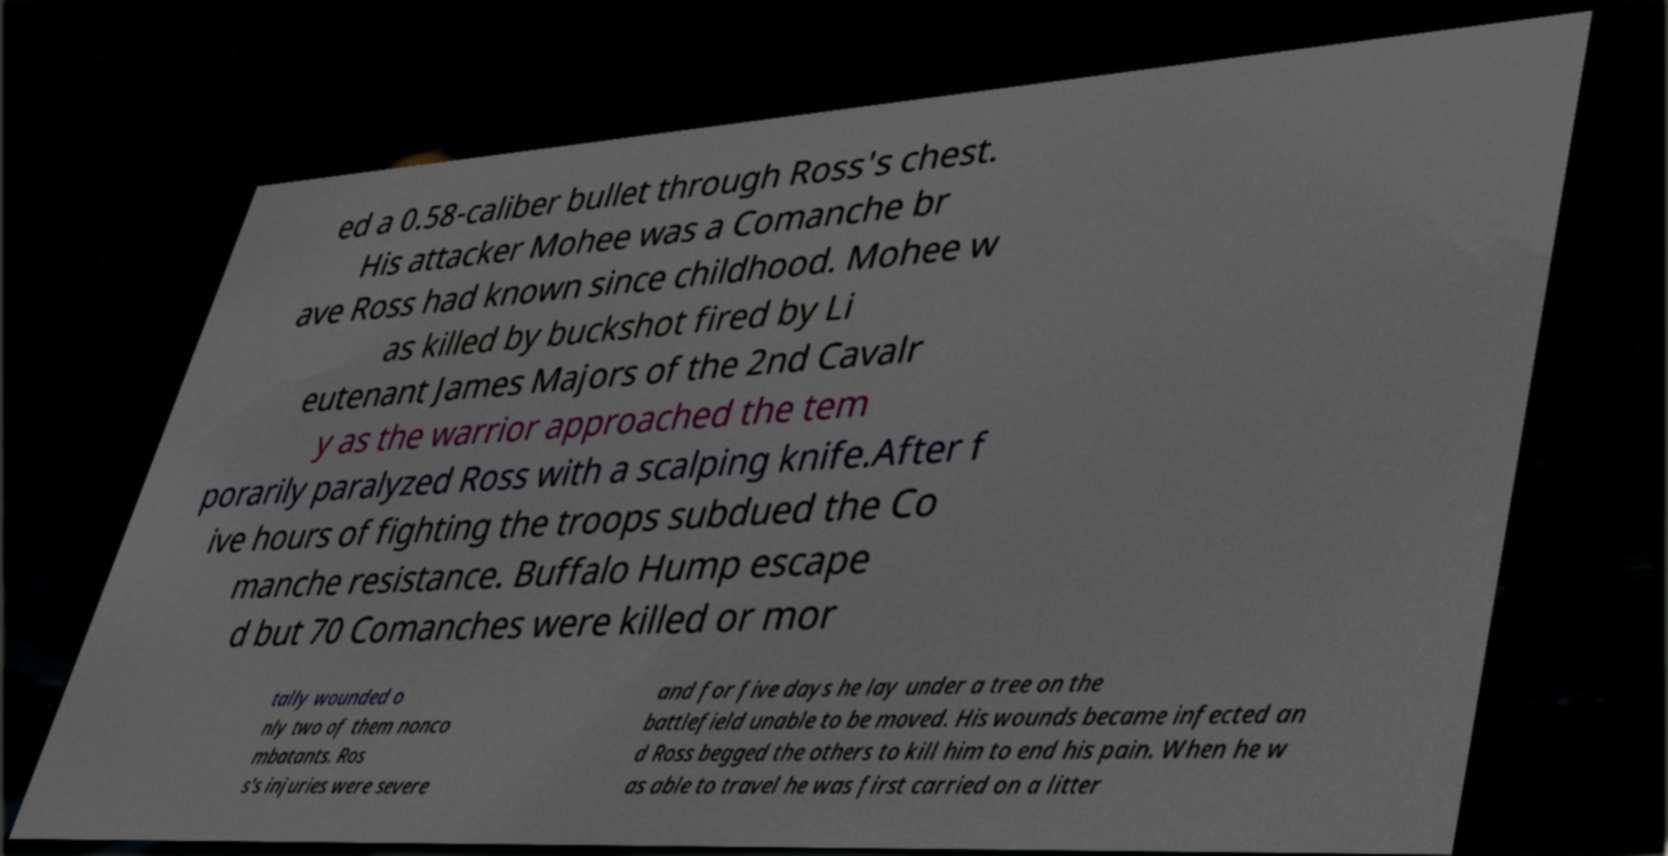What messages or text are displayed in this image? I need them in a readable, typed format. ed a 0.58-caliber bullet through Ross's chest. His attacker Mohee was a Comanche br ave Ross had known since childhood. Mohee w as killed by buckshot fired by Li eutenant James Majors of the 2nd Cavalr y as the warrior approached the tem porarily paralyzed Ross with a scalping knife.After f ive hours of fighting the troops subdued the Co manche resistance. Buffalo Hump escape d but 70 Comanches were killed or mor tally wounded o nly two of them nonco mbatants. Ros s's injuries were severe and for five days he lay under a tree on the battlefield unable to be moved. His wounds became infected an d Ross begged the others to kill him to end his pain. When he w as able to travel he was first carried on a litter 